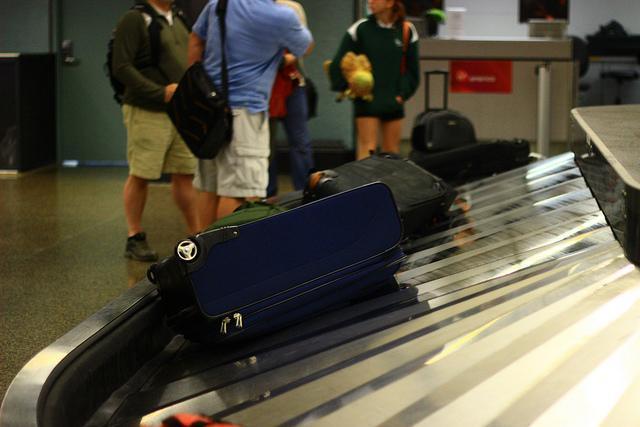How many people in the background are wearing pants?
Give a very brief answer. 1. How many people are standing at the luggage carrier?
Give a very brief answer. 4. How many suitcases are in the photo?
Give a very brief answer. 4. How many people are there?
Give a very brief answer. 4. How many chairs are visible?
Give a very brief answer. 0. 